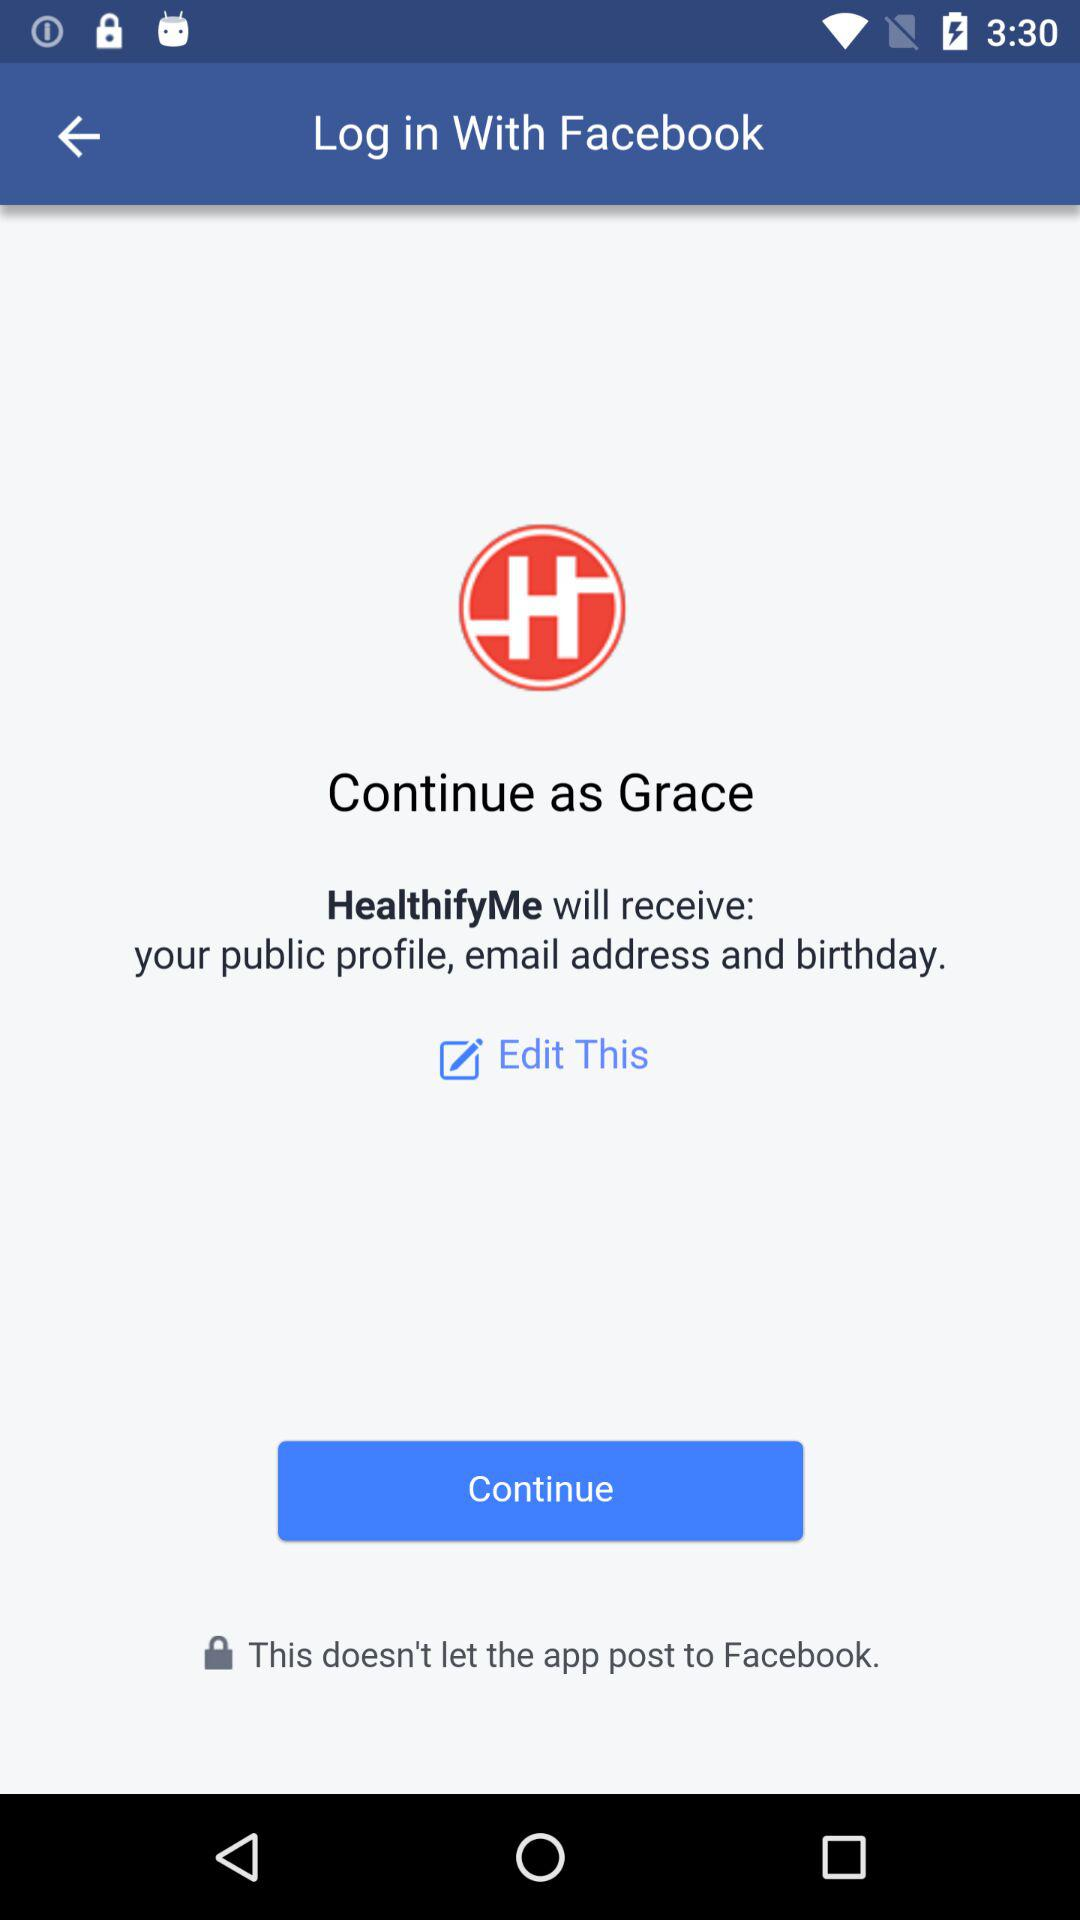Through what application can we log in? You can log in through "Facebook". 